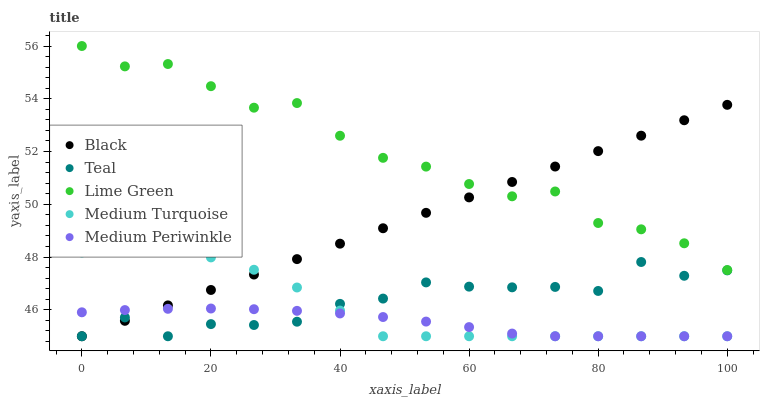Does Medium Periwinkle have the minimum area under the curve?
Answer yes or no. Yes. Does Lime Green have the maximum area under the curve?
Answer yes or no. Yes. Does Black have the minimum area under the curve?
Answer yes or no. No. Does Black have the maximum area under the curve?
Answer yes or no. No. Is Black the smoothest?
Answer yes or no. Yes. Is Teal the roughest?
Answer yes or no. Yes. Is Medium Turquoise the smoothest?
Answer yes or no. No. Is Medium Turquoise the roughest?
Answer yes or no. No. Does Black have the lowest value?
Answer yes or no. Yes. Does Lime Green have the highest value?
Answer yes or no. Yes. Does Black have the highest value?
Answer yes or no. No. Is Medium Turquoise less than Lime Green?
Answer yes or no. Yes. Is Lime Green greater than Teal?
Answer yes or no. Yes. Does Medium Turquoise intersect Black?
Answer yes or no. Yes. Is Medium Turquoise less than Black?
Answer yes or no. No. Is Medium Turquoise greater than Black?
Answer yes or no. No. Does Medium Turquoise intersect Lime Green?
Answer yes or no. No. 